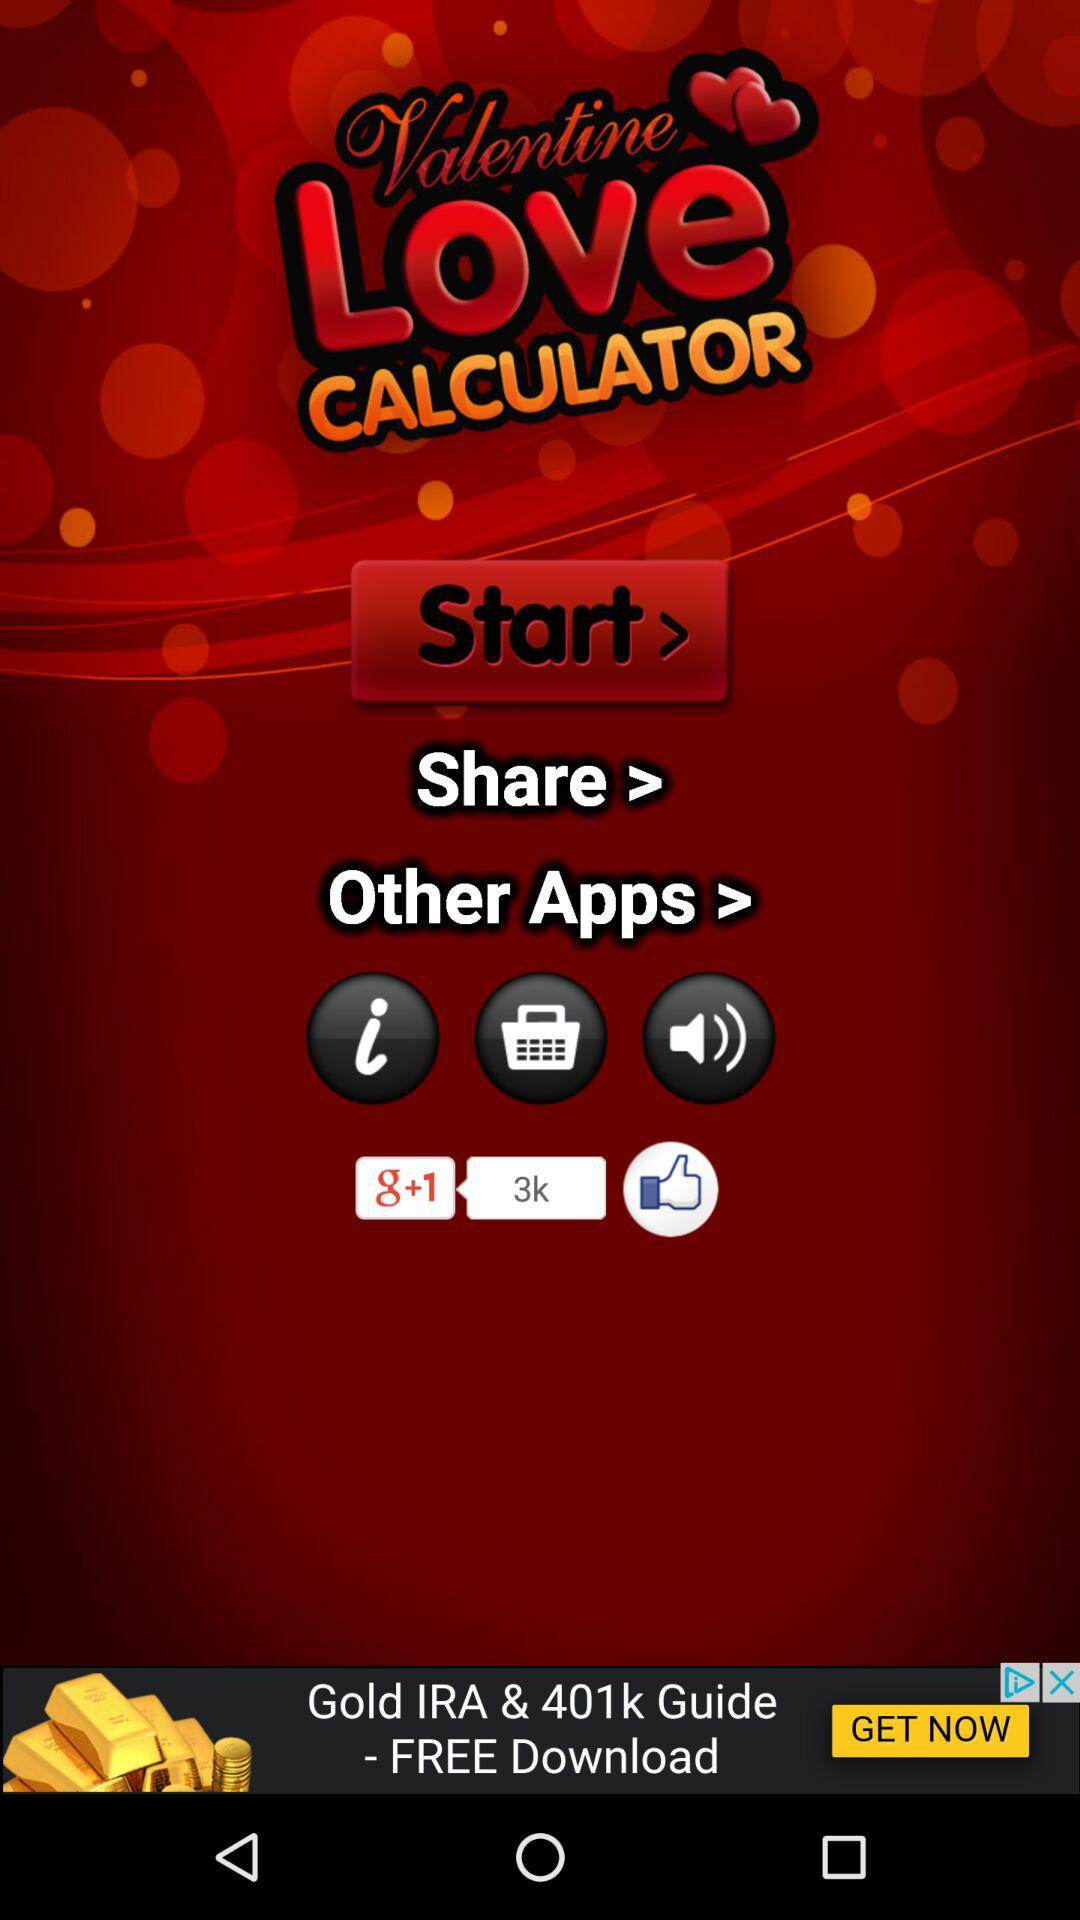What is the count of likes on the app "g+1"? The count of likes is 3k. 